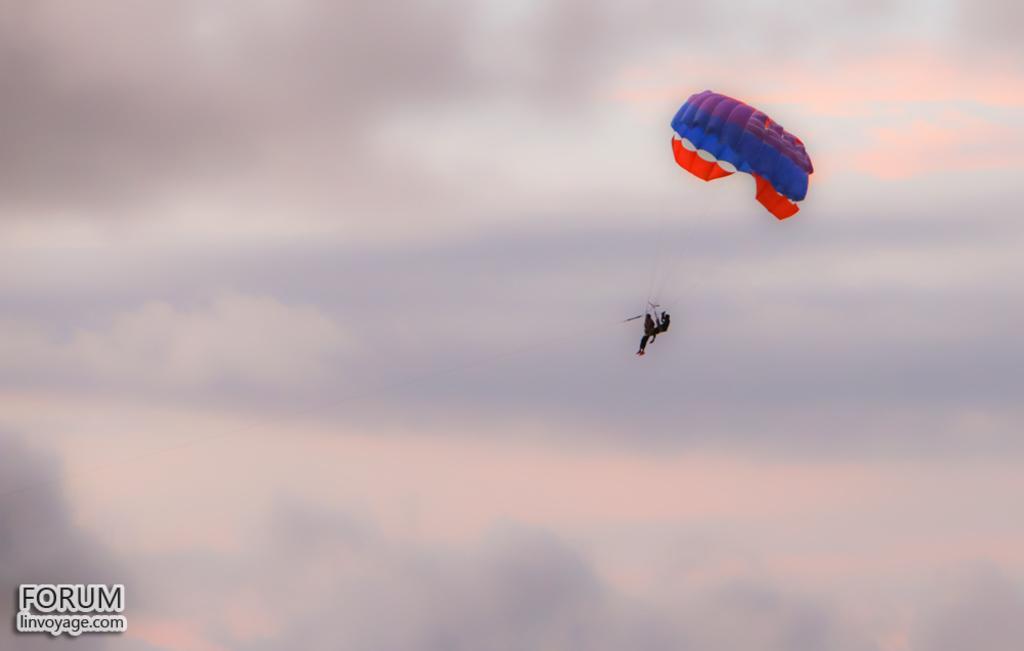Could you give a brief overview of what you see in this image? In this image, we can see a person sliding under the parachute in the air. Background we can see the cloudy sky. On the left side bottom corner, we can see the watermarks in the image. 